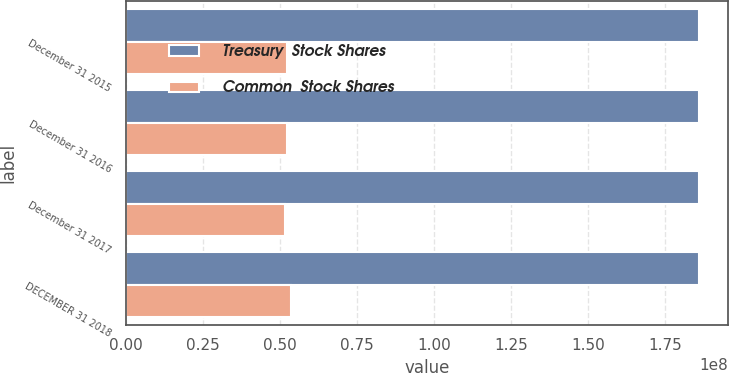<chart> <loc_0><loc_0><loc_500><loc_500><stacked_bar_chart><ecel><fcel>December 31 2015<fcel>December 31 2016<fcel>December 31 2017<fcel>DECEMBER 31 2018<nl><fcel>Treasury  Stock Shares<fcel>1.85984e+08<fcel>1.85984e+08<fcel>1.85984e+08<fcel>1.85984e+08<nl><fcel>Common  Stock Shares<fcel>5.2328e+07<fcel>5.22937e+07<fcel>5.16532e+07<fcel>5.37022e+07<nl></chart> 